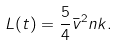<formula> <loc_0><loc_0><loc_500><loc_500>L ( t ) = \frac { 5 } { 4 } \bar { v } ^ { 2 } n k .</formula> 